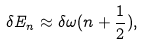Convert formula to latex. <formula><loc_0><loc_0><loc_500><loc_500>\delta E _ { n } \approx \delta \omega ( n + \frac { 1 } { 2 } ) ,</formula> 